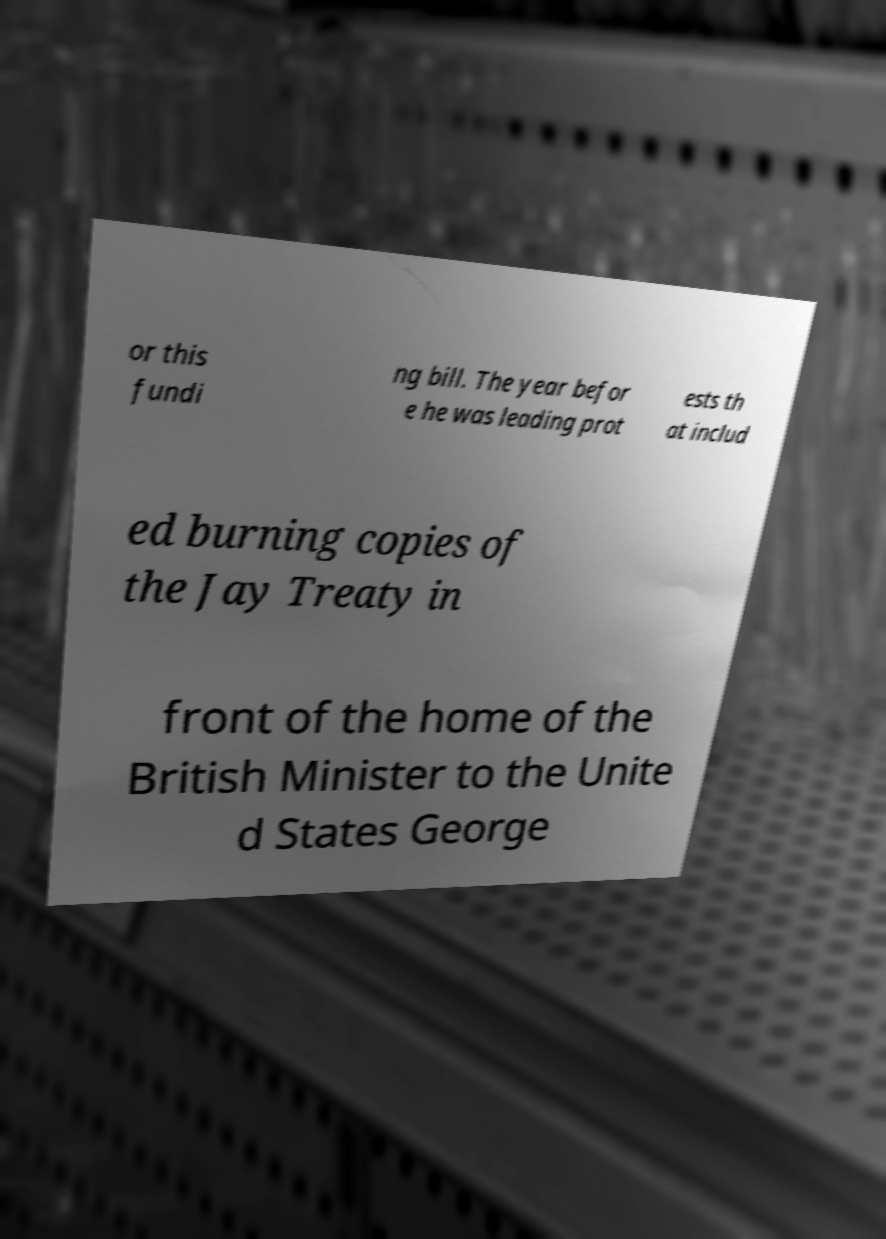Please read and relay the text visible in this image. What does it say? or this fundi ng bill. The year befor e he was leading prot ests th at includ ed burning copies of the Jay Treaty in front of the home of the British Minister to the Unite d States George 